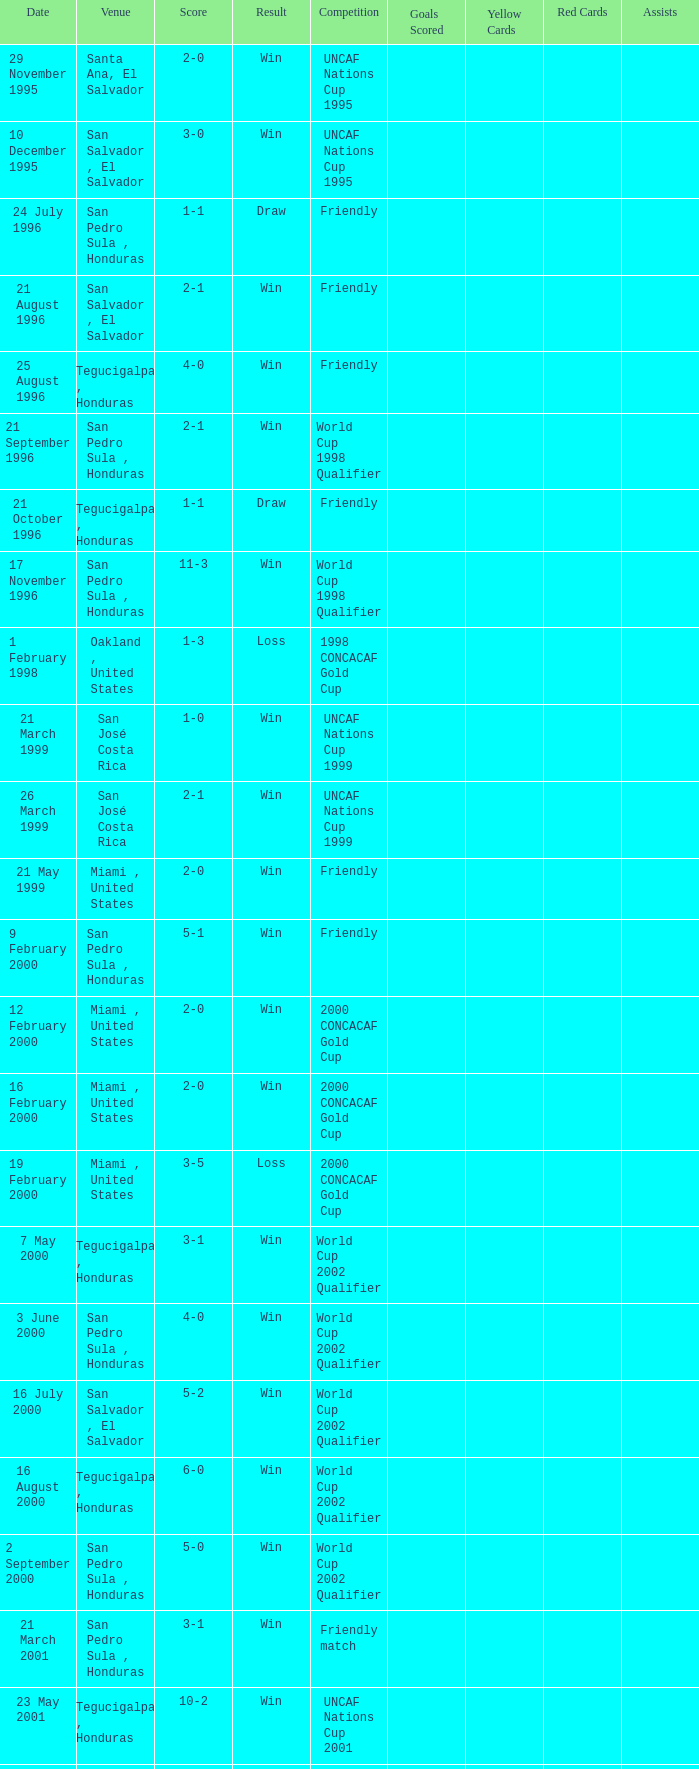Can you provide the score for may 7th, 2000? 3-1. Would you mind parsing the complete table? {'header': ['Date', 'Venue', 'Score', 'Result', 'Competition', 'Goals Scored', 'Yellow Cards', 'Red Cards', 'Assists'], 'rows': [['29 November 1995', 'Santa Ana, El Salvador', '2-0', 'Win', 'UNCAF Nations Cup 1995', '', '', '', ''], ['10 December 1995', 'San Salvador , El Salvador', '3-0', 'Win', 'UNCAF Nations Cup 1995', '', '', '', ''], ['24 July 1996', 'San Pedro Sula , Honduras', '1-1', 'Draw', 'Friendly', '', '', '', ''], ['21 August 1996', 'San Salvador , El Salvador', '2-1', 'Win', 'Friendly', '', '', '', ''], ['25 August 1996', 'Tegucigalpa , Honduras', '4-0', 'Win', 'Friendly', '', '', '', ''], ['21 September 1996', 'San Pedro Sula , Honduras', '2-1', 'Win', 'World Cup 1998 Qualifier', '', '', '', ''], ['21 October 1996', 'Tegucigalpa , Honduras', '1-1', 'Draw', 'Friendly', '', '', '', ''], ['17 November 1996', 'San Pedro Sula , Honduras', '11-3', 'Win', 'World Cup 1998 Qualifier', '', '', '', ''], ['1 February 1998', 'Oakland , United States', '1-3', 'Loss', '1998 CONCACAF Gold Cup', '', '', '', ''], ['21 March 1999', 'San José Costa Rica', '1-0', 'Win', 'UNCAF Nations Cup 1999', '', '', '', ''], ['26 March 1999', 'San José Costa Rica', '2-1', 'Win', 'UNCAF Nations Cup 1999', '', '', '', ''], ['21 May 1999', 'Miami , United States', '2-0', 'Win', 'Friendly', '', '', '', ''], ['9 February 2000', 'San Pedro Sula , Honduras', '5-1', 'Win', 'Friendly', '', '', '', ''], ['12 February 2000', 'Miami , United States', '2-0', 'Win', '2000 CONCACAF Gold Cup', '', '', '', ''], ['16 February 2000', 'Miami , United States', '2-0', 'Win', '2000 CONCACAF Gold Cup', '', '', '', ''], ['19 February 2000', 'Miami , United States', '3-5', 'Loss', '2000 CONCACAF Gold Cup', '', '', '', ''], ['7 May 2000', 'Tegucigalpa , Honduras', '3-1', 'Win', 'World Cup 2002 Qualifier', '', '', '', ''], ['3 June 2000', 'San Pedro Sula , Honduras', '4-0', 'Win', 'World Cup 2002 Qualifier', '', '', '', ''], ['16 July 2000', 'San Salvador , El Salvador', '5-2', 'Win', 'World Cup 2002 Qualifier', '', '', '', ''], ['16 August 2000', 'Tegucigalpa , Honduras', '6-0', 'Win', 'World Cup 2002 Qualifier', '', '', '', ''], ['2 September 2000', 'San Pedro Sula , Honduras', '5-0', 'Win', 'World Cup 2002 Qualifier', '', '', '', ''], ['21 March 2001', 'San Pedro Sula , Honduras', '3-1', 'Win', 'Friendly match', '', '', '', ''], ['23 May 2001', 'Tegucigalpa , Honduras', '10-2', 'Win', 'UNCAF Nations Cup 2001', '', '', '', ''], ['16 June 2001', 'Port of Spain , Trinidad and Tobago', '4-2', 'Win', 'World Cup 2002 Qualifier', '', '', '', ''], ['20 June 2001', 'San Pedro Sula , Honduras', '3-1', 'Win', 'World Cup 2002 Qualifier', '', '', '', ''], ['1 September 2001', 'Washington, D.C. , United States', '2-1', 'Win', 'World Cup 2002 Qualifier', '', '', '', ''], ['2 May 2002', 'Kobe , Japan', '3-3', 'Draw', 'Carlsberg Cup', '', '', '', ''], ['28 April 2004', 'Fort Lauderdale , United States', '1-1', 'Draw', 'Friendly', '', '', '', ''], ['19 June 2004', 'San Pedro Sula , Honduras', '4-0', 'Win', 'World Cup 2006 Qualification', '', '', '', ''], ['19 April 2007', 'La Ceiba , Honduras', '1-3', 'Loss', 'Friendly', '', '', '', ''], ['25 May 2007', 'Mérida , Venezuela', '1-2', 'Loss', 'Friendly', '', '', '', ''], ['13 June 2007', 'Houston , United States', '5-0', 'Win', '2007 CONCACAF Gold Cup', '', '', '', ''], ['17 June 2007', 'Houston , United States', '1-2', 'Loss', '2007 CONCACAF Gold Cup', '', '', '', ''], ['18 January 2009', 'Miami , United States', '2-0', 'Win', 'Friendly', '', '', '', ''], ['26 January 2009', 'Tegucigalpa , Honduras', '2-0', 'Win', 'UNCAF Nations Cup 2009', '', '', '', ''], ['28 March 2009', 'Port of Spain , Trinidad and Tobago', '1-1', 'Draw', 'World Cup 2010 Qualification', '', '', '', ''], ['1 April 2009', 'San Pedro Sula , Honduras', '3-1', 'Win', 'World Cup 2010 Qualification', '', '', '', ''], ['10 June 2009', 'San Pedro Sula , Honduras', '1-0', 'Win', 'World Cup 2010 Qualification', '', '', '', ''], ['12 August 2009', 'San Pedro Sula , Honduras', '4-0', 'Win', 'World Cup 2010 Qualification', '', '', '', ''], ['5 September 2009', 'San Pedro Sula , Honduras', '4-1', 'Win', 'World Cup 2010 Qualification', '', '', '', ''], ['14 October 2009', 'San Salvador , El Salvador', '1-0', 'Win', 'World Cup 2010 Qualification', '', '', '', ''], ['23 January 2010', 'Carson , United States', '3-1', 'Win', 'Friendly', '', '', '', '']]} 